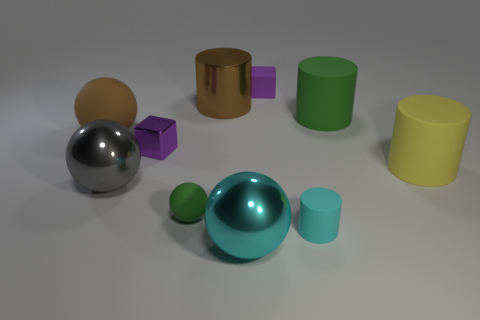Subtract 1 cylinders. How many cylinders are left? 3 Subtract all spheres. How many objects are left? 6 Add 8 small purple cubes. How many small purple cubes are left? 10 Add 7 small yellow blocks. How many small yellow blocks exist? 7 Subtract 0 gray cubes. How many objects are left? 10 Subtract all large yellow metallic spheres. Subtract all brown metallic cylinders. How many objects are left? 9 